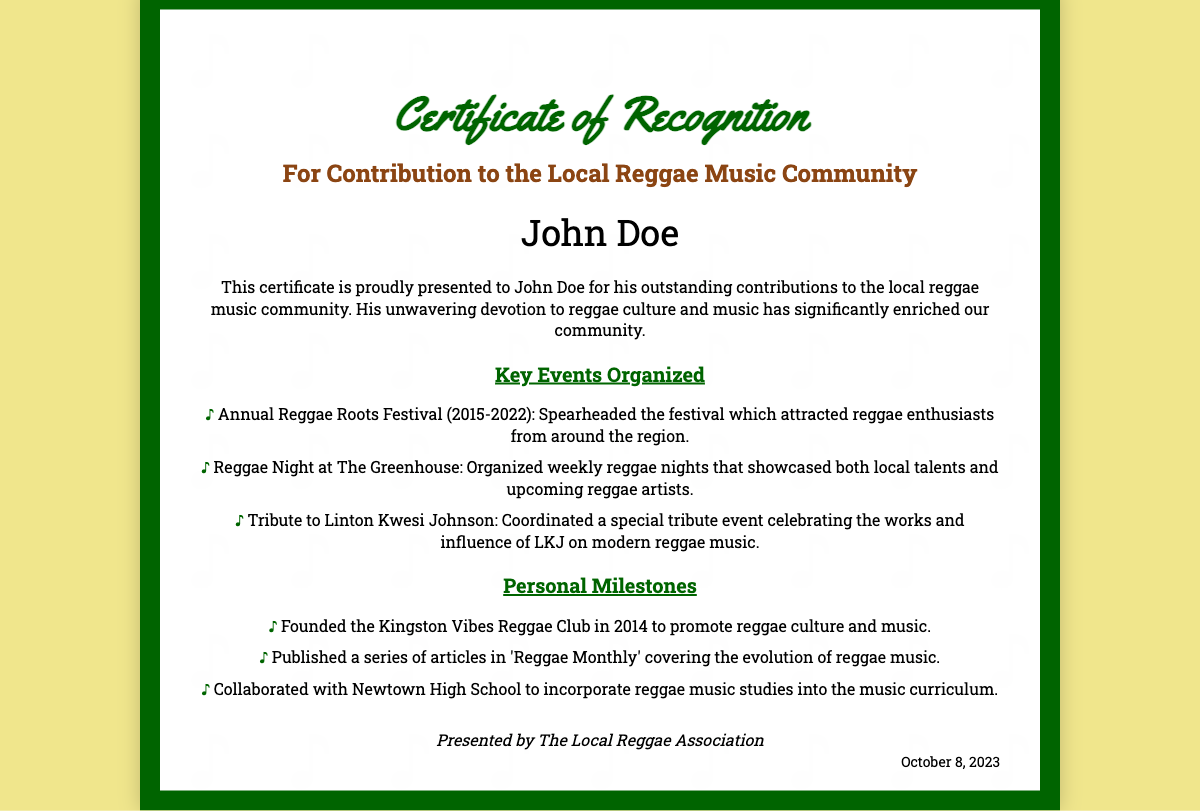What is the name of the recipient? The recipient's name is explicitly mentioned in the document.
Answer: John Doe In what year did the Annual Reggae Roots Festival start? The document lists the time frame of the festival's organization, starting from the first year.
Answer: 2015 What organization presented the certificate? The presenting organization is stated in the footer of the document.
Answer: The Local Reggae Association How many personal milestones are listed in the document? The document provides a specific number of personal milestones under the related section.
Answer: 3 What is one of the key events organized by John Doe? The document specifies several events organized by the recipient.
Answer: Annual Reggae Roots Festival Which significant figure in reggae music is mentioned in the document? The document highlights a specific artist known for their influence in reggae music.
Answer: Linton Kwesi Johnson What year was the Kingston Vibes Reggae Club founded? The founding year of the club is mentioned in the personal milestones section.
Answer: 2014 When was the certificate presented? The presentation date is noted at the bottom of the certificate.
Answer: October 8, 2023 